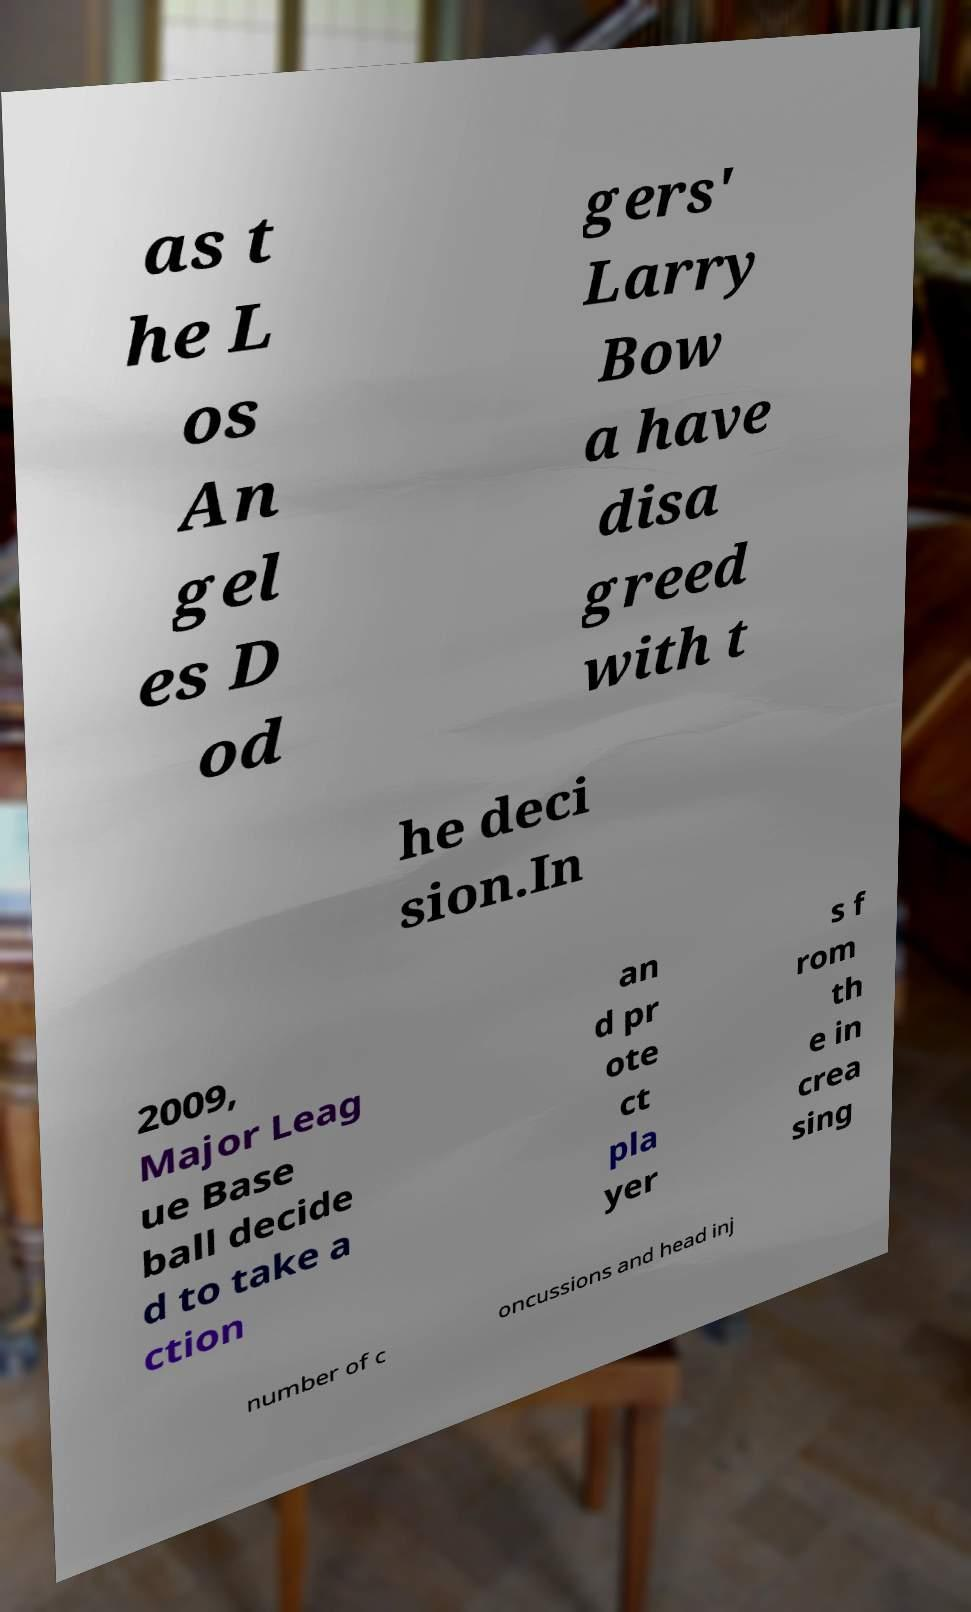Please read and relay the text visible in this image. What does it say? as t he L os An gel es D od gers' Larry Bow a have disa greed with t he deci sion.In 2009, Major Leag ue Base ball decide d to take a ction an d pr ote ct pla yer s f rom th e in crea sing number of c oncussions and head inj 